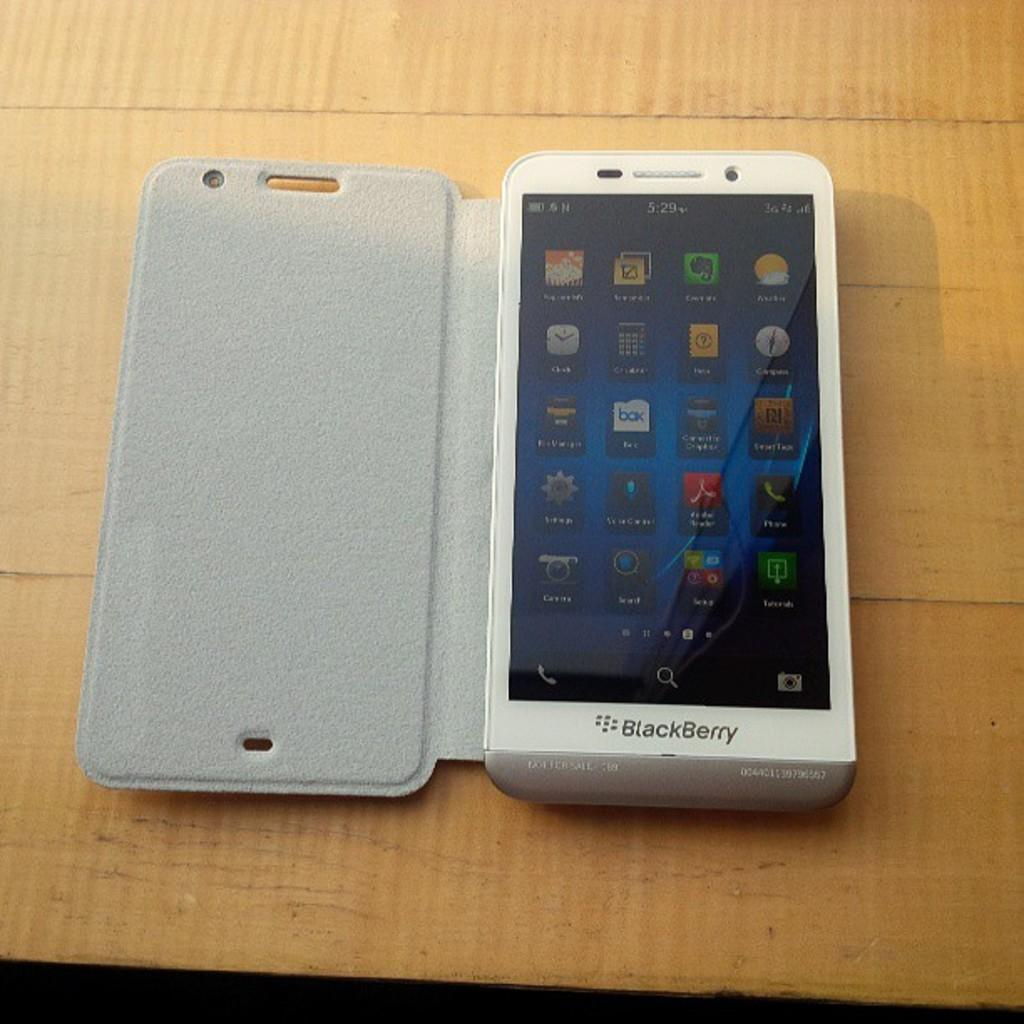<image>
Relay a brief, clear account of the picture shown. A BlackBerry phone with its case open displays a large number of icons on its home screen. 